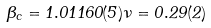<formula> <loc_0><loc_0><loc_500><loc_500>\beta _ { c } = 1 . 0 1 1 6 0 ( 5 ) \nu = 0 . 2 9 ( 2 )</formula> 